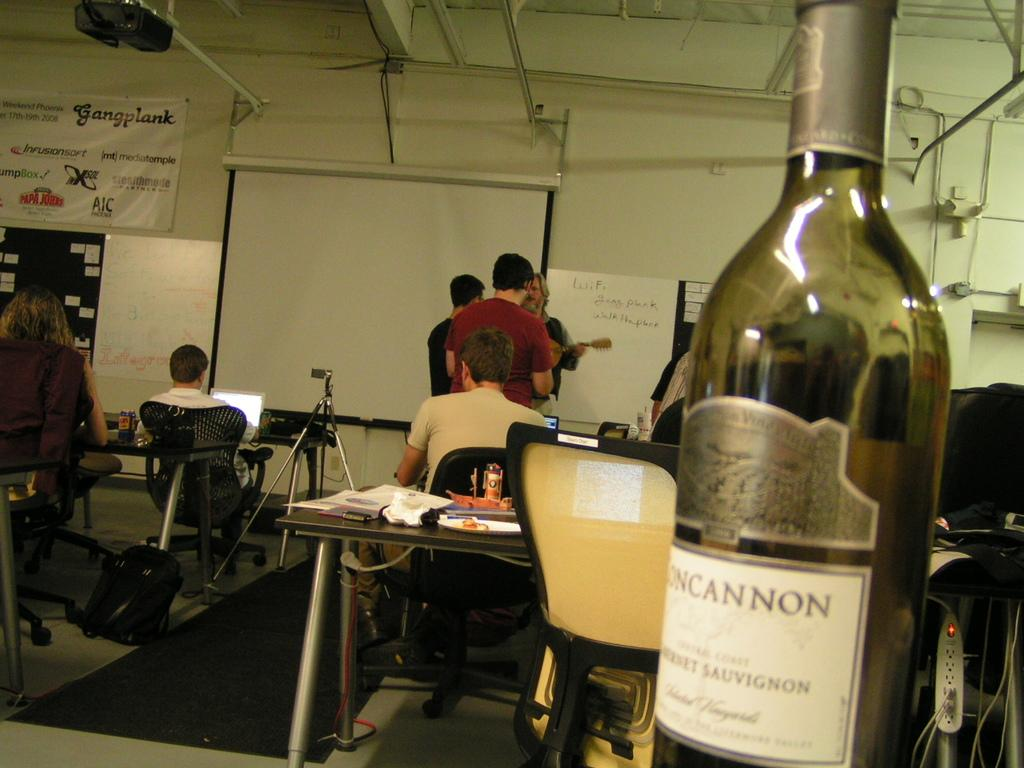<image>
Share a concise interpretation of the image provided. a bottle of wine from Cannon sits on a desk in a classroom 